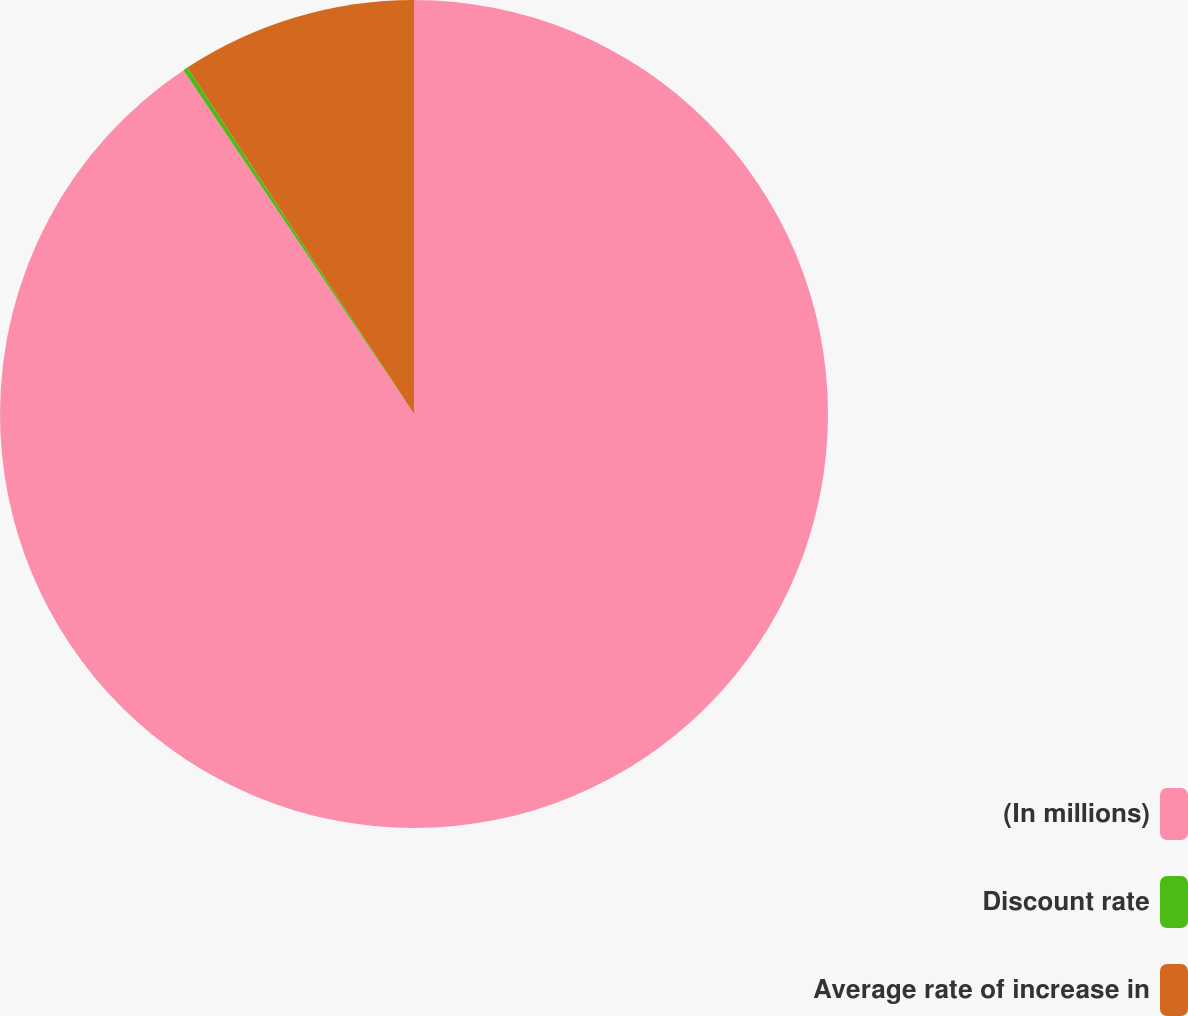Convert chart to OTSL. <chart><loc_0><loc_0><loc_500><loc_500><pie_chart><fcel>(In millions)<fcel>Discount rate<fcel>Average rate of increase in<nl><fcel>90.6%<fcel>0.18%<fcel>9.22%<nl></chart> 